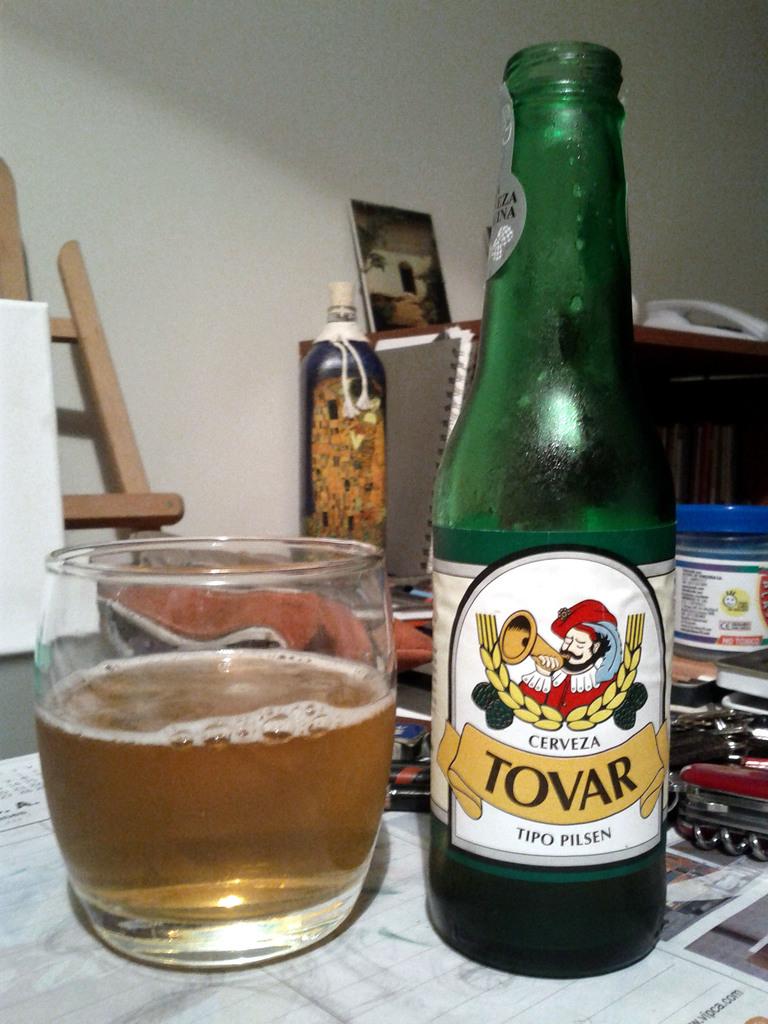What is the brand of beer?
Your answer should be compact. Tovar. What is the beer's specific flavor?
Provide a short and direct response. Tovar. 